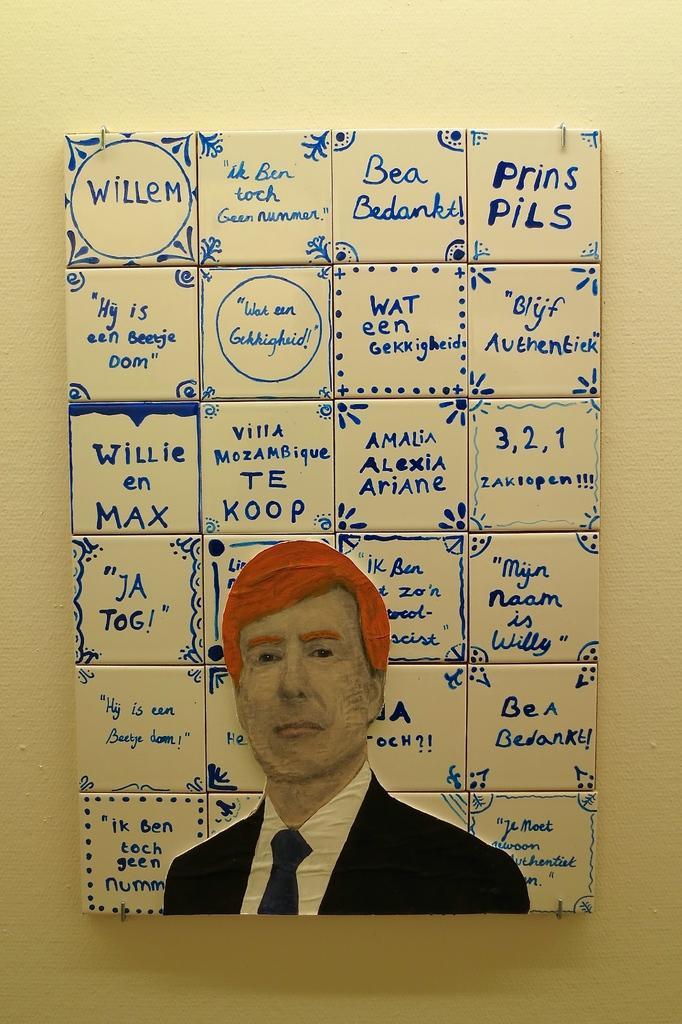Can you describe this image briefly? In this image we can see a paper on which one person picture was drawn and some text was written on the cubes. 